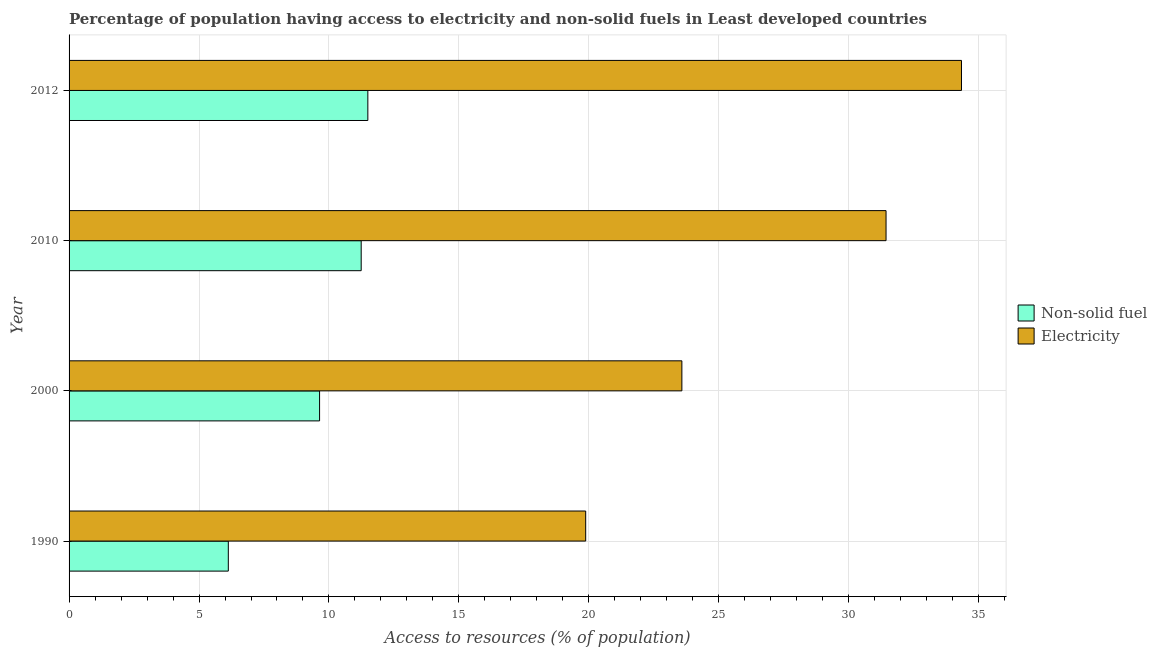Are the number of bars per tick equal to the number of legend labels?
Offer a terse response. Yes. How many bars are there on the 2nd tick from the top?
Your response must be concise. 2. What is the label of the 1st group of bars from the top?
Keep it short and to the point. 2012. In how many cases, is the number of bars for a given year not equal to the number of legend labels?
Provide a succinct answer. 0. What is the percentage of population having access to electricity in 2010?
Your answer should be very brief. 31.44. Across all years, what is the maximum percentage of population having access to electricity?
Offer a very short reply. 34.34. Across all years, what is the minimum percentage of population having access to electricity?
Your answer should be very brief. 19.88. In which year was the percentage of population having access to electricity maximum?
Your answer should be compact. 2012. In which year was the percentage of population having access to non-solid fuel minimum?
Your response must be concise. 1990. What is the total percentage of population having access to non-solid fuel in the graph?
Offer a very short reply. 38.5. What is the difference between the percentage of population having access to non-solid fuel in 2000 and that in 2010?
Provide a succinct answer. -1.6. What is the difference between the percentage of population having access to non-solid fuel in 2000 and the percentage of population having access to electricity in 2012?
Your response must be concise. -24.7. What is the average percentage of population having access to non-solid fuel per year?
Your answer should be very brief. 9.62. In the year 2000, what is the difference between the percentage of population having access to electricity and percentage of population having access to non-solid fuel?
Make the answer very short. 13.94. What is the ratio of the percentage of population having access to electricity in 2000 to that in 2012?
Offer a terse response. 0.69. Is the difference between the percentage of population having access to non-solid fuel in 2010 and 2012 greater than the difference between the percentage of population having access to electricity in 2010 and 2012?
Your answer should be very brief. Yes. What is the difference between the highest and the second highest percentage of population having access to non-solid fuel?
Your answer should be very brief. 0.26. What is the difference between the highest and the lowest percentage of population having access to non-solid fuel?
Provide a short and direct response. 5.37. What does the 2nd bar from the top in 2000 represents?
Provide a succinct answer. Non-solid fuel. What does the 2nd bar from the bottom in 2012 represents?
Keep it short and to the point. Electricity. How many years are there in the graph?
Offer a terse response. 4. Are the values on the major ticks of X-axis written in scientific E-notation?
Offer a terse response. No. Does the graph contain any zero values?
Your answer should be very brief. No. What is the title of the graph?
Offer a terse response. Percentage of population having access to electricity and non-solid fuels in Least developed countries. What is the label or title of the X-axis?
Your answer should be very brief. Access to resources (% of population). What is the Access to resources (% of population) of Non-solid fuel in 1990?
Provide a short and direct response. 6.13. What is the Access to resources (% of population) of Electricity in 1990?
Ensure brevity in your answer.  19.88. What is the Access to resources (% of population) of Non-solid fuel in 2000?
Ensure brevity in your answer.  9.64. What is the Access to resources (% of population) in Electricity in 2000?
Offer a terse response. 23.58. What is the Access to resources (% of population) of Non-solid fuel in 2010?
Offer a terse response. 11.24. What is the Access to resources (% of population) in Electricity in 2010?
Your answer should be compact. 31.44. What is the Access to resources (% of population) of Non-solid fuel in 2012?
Your answer should be compact. 11.5. What is the Access to resources (% of population) in Electricity in 2012?
Your answer should be very brief. 34.34. Across all years, what is the maximum Access to resources (% of population) in Non-solid fuel?
Offer a terse response. 11.5. Across all years, what is the maximum Access to resources (% of population) of Electricity?
Offer a terse response. 34.34. Across all years, what is the minimum Access to resources (% of population) in Non-solid fuel?
Give a very brief answer. 6.13. Across all years, what is the minimum Access to resources (% of population) of Electricity?
Your answer should be very brief. 19.88. What is the total Access to resources (% of population) in Non-solid fuel in the graph?
Offer a terse response. 38.5. What is the total Access to resources (% of population) of Electricity in the graph?
Provide a short and direct response. 109.23. What is the difference between the Access to resources (% of population) of Non-solid fuel in 1990 and that in 2000?
Your response must be concise. -3.51. What is the difference between the Access to resources (% of population) in Electricity in 1990 and that in 2000?
Give a very brief answer. -3.7. What is the difference between the Access to resources (% of population) in Non-solid fuel in 1990 and that in 2010?
Your response must be concise. -5.11. What is the difference between the Access to resources (% of population) of Electricity in 1990 and that in 2010?
Give a very brief answer. -11.56. What is the difference between the Access to resources (% of population) in Non-solid fuel in 1990 and that in 2012?
Make the answer very short. -5.37. What is the difference between the Access to resources (% of population) in Electricity in 1990 and that in 2012?
Make the answer very short. -14.46. What is the difference between the Access to resources (% of population) of Non-solid fuel in 2000 and that in 2010?
Give a very brief answer. -1.6. What is the difference between the Access to resources (% of population) of Electricity in 2000 and that in 2010?
Ensure brevity in your answer.  -7.86. What is the difference between the Access to resources (% of population) in Non-solid fuel in 2000 and that in 2012?
Make the answer very short. -1.86. What is the difference between the Access to resources (% of population) of Electricity in 2000 and that in 2012?
Give a very brief answer. -10.76. What is the difference between the Access to resources (% of population) of Non-solid fuel in 2010 and that in 2012?
Your answer should be very brief. -0.26. What is the difference between the Access to resources (% of population) of Electricity in 2010 and that in 2012?
Your answer should be very brief. -2.9. What is the difference between the Access to resources (% of population) of Non-solid fuel in 1990 and the Access to resources (% of population) of Electricity in 2000?
Offer a very short reply. -17.45. What is the difference between the Access to resources (% of population) in Non-solid fuel in 1990 and the Access to resources (% of population) in Electricity in 2010?
Offer a terse response. -25.31. What is the difference between the Access to resources (% of population) of Non-solid fuel in 1990 and the Access to resources (% of population) of Electricity in 2012?
Make the answer very short. -28.21. What is the difference between the Access to resources (% of population) of Non-solid fuel in 2000 and the Access to resources (% of population) of Electricity in 2010?
Your answer should be very brief. -21.8. What is the difference between the Access to resources (% of population) of Non-solid fuel in 2000 and the Access to resources (% of population) of Electricity in 2012?
Offer a very short reply. -24.7. What is the difference between the Access to resources (% of population) of Non-solid fuel in 2010 and the Access to resources (% of population) of Electricity in 2012?
Give a very brief answer. -23.1. What is the average Access to resources (% of population) of Non-solid fuel per year?
Ensure brevity in your answer.  9.63. What is the average Access to resources (% of population) of Electricity per year?
Provide a short and direct response. 27.31. In the year 1990, what is the difference between the Access to resources (% of population) of Non-solid fuel and Access to resources (% of population) of Electricity?
Your response must be concise. -13.75. In the year 2000, what is the difference between the Access to resources (% of population) in Non-solid fuel and Access to resources (% of population) in Electricity?
Offer a terse response. -13.94. In the year 2010, what is the difference between the Access to resources (% of population) in Non-solid fuel and Access to resources (% of population) in Electricity?
Offer a very short reply. -20.2. In the year 2012, what is the difference between the Access to resources (% of population) of Non-solid fuel and Access to resources (% of population) of Electricity?
Give a very brief answer. -22.84. What is the ratio of the Access to resources (% of population) of Non-solid fuel in 1990 to that in 2000?
Your answer should be very brief. 0.64. What is the ratio of the Access to resources (% of population) of Electricity in 1990 to that in 2000?
Provide a short and direct response. 0.84. What is the ratio of the Access to resources (% of population) in Non-solid fuel in 1990 to that in 2010?
Keep it short and to the point. 0.55. What is the ratio of the Access to resources (% of population) of Electricity in 1990 to that in 2010?
Your response must be concise. 0.63. What is the ratio of the Access to resources (% of population) of Non-solid fuel in 1990 to that in 2012?
Your answer should be very brief. 0.53. What is the ratio of the Access to resources (% of population) of Electricity in 1990 to that in 2012?
Provide a short and direct response. 0.58. What is the ratio of the Access to resources (% of population) of Non-solid fuel in 2000 to that in 2010?
Make the answer very short. 0.86. What is the ratio of the Access to resources (% of population) in Electricity in 2000 to that in 2010?
Provide a short and direct response. 0.75. What is the ratio of the Access to resources (% of population) in Non-solid fuel in 2000 to that in 2012?
Offer a very short reply. 0.84. What is the ratio of the Access to resources (% of population) of Electricity in 2000 to that in 2012?
Ensure brevity in your answer.  0.69. What is the ratio of the Access to resources (% of population) of Non-solid fuel in 2010 to that in 2012?
Offer a terse response. 0.98. What is the ratio of the Access to resources (% of population) of Electricity in 2010 to that in 2012?
Ensure brevity in your answer.  0.92. What is the difference between the highest and the second highest Access to resources (% of population) of Non-solid fuel?
Your answer should be compact. 0.26. What is the difference between the highest and the second highest Access to resources (% of population) of Electricity?
Offer a terse response. 2.9. What is the difference between the highest and the lowest Access to resources (% of population) in Non-solid fuel?
Your answer should be very brief. 5.37. What is the difference between the highest and the lowest Access to resources (% of population) of Electricity?
Your response must be concise. 14.46. 